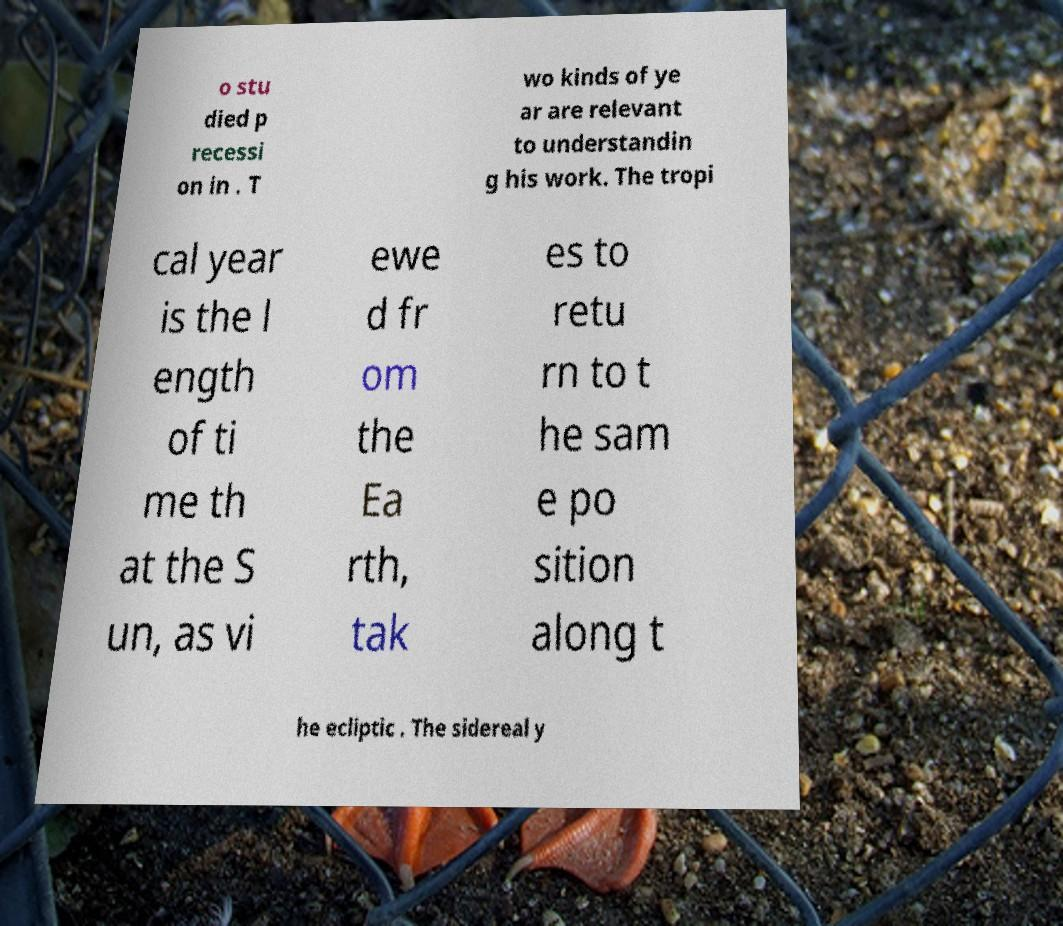What messages or text are displayed in this image? I need them in a readable, typed format. o stu died p recessi on in . T wo kinds of ye ar are relevant to understandin g his work. The tropi cal year is the l ength of ti me th at the S un, as vi ewe d fr om the Ea rth, tak es to retu rn to t he sam e po sition along t he ecliptic . The sidereal y 